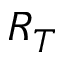Convert formula to latex. <formula><loc_0><loc_0><loc_500><loc_500>R _ { T }</formula> 